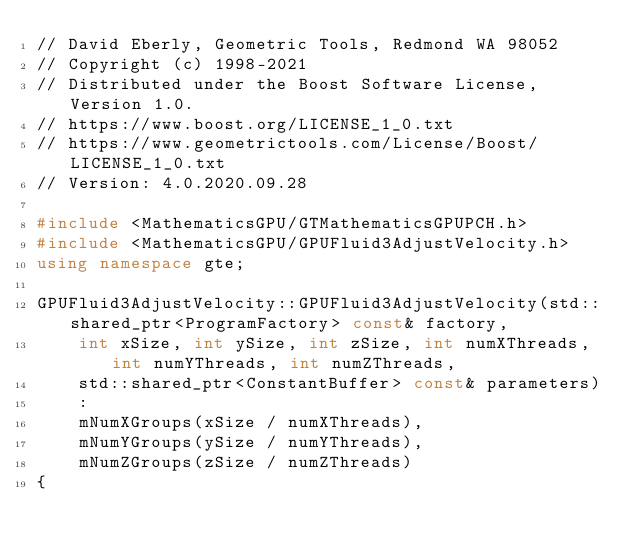<code> <loc_0><loc_0><loc_500><loc_500><_C++_>// David Eberly, Geometric Tools, Redmond WA 98052
// Copyright (c) 1998-2021
// Distributed under the Boost Software License, Version 1.0.
// https://www.boost.org/LICENSE_1_0.txt
// https://www.geometrictools.com/License/Boost/LICENSE_1_0.txt
// Version: 4.0.2020.09.28

#include <MathematicsGPU/GTMathematicsGPUPCH.h>
#include <MathematicsGPU/GPUFluid3AdjustVelocity.h>
using namespace gte;

GPUFluid3AdjustVelocity::GPUFluid3AdjustVelocity(std::shared_ptr<ProgramFactory> const& factory,
    int xSize, int ySize, int zSize, int numXThreads, int numYThreads, int numZThreads,
    std::shared_ptr<ConstantBuffer> const& parameters)
    :
    mNumXGroups(xSize / numXThreads),
    mNumYGroups(ySize / numYThreads),
    mNumZGroups(zSize / numZThreads)
{</code> 